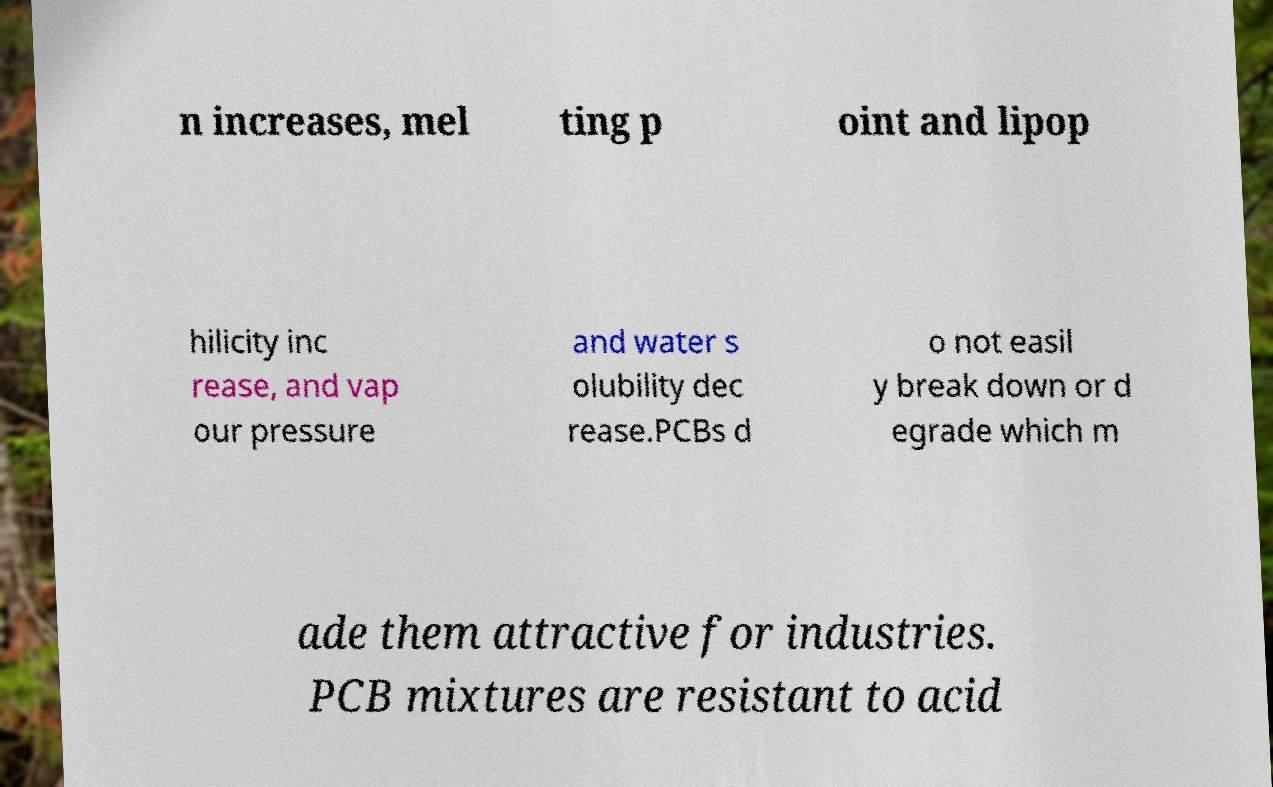What messages or text are displayed in this image? I need them in a readable, typed format. n increases, mel ting p oint and lipop hilicity inc rease, and vap our pressure and water s olubility dec rease.PCBs d o not easil y break down or d egrade which m ade them attractive for industries. PCB mixtures are resistant to acid 